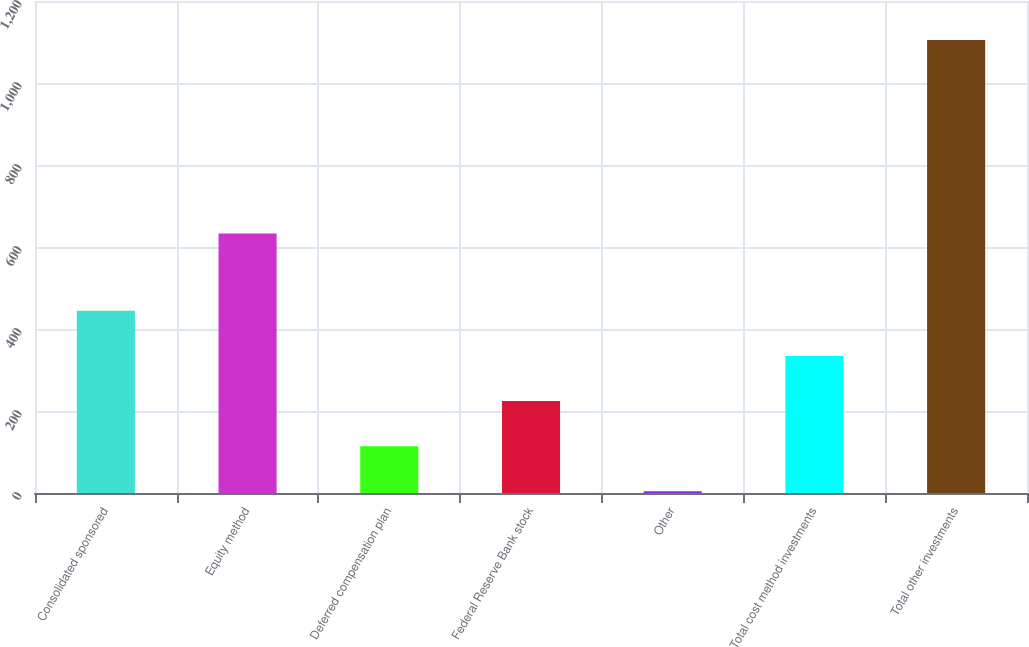<chart> <loc_0><loc_0><loc_500><loc_500><bar_chart><fcel>Consolidated sponsored<fcel>Equity method<fcel>Deferred compensation plan<fcel>Federal Reserve Bank stock<fcel>Other<fcel>Total cost method investments<fcel>Total other investments<nl><fcel>444.4<fcel>633<fcel>114.1<fcel>224.2<fcel>4<fcel>334.3<fcel>1105<nl></chart> 